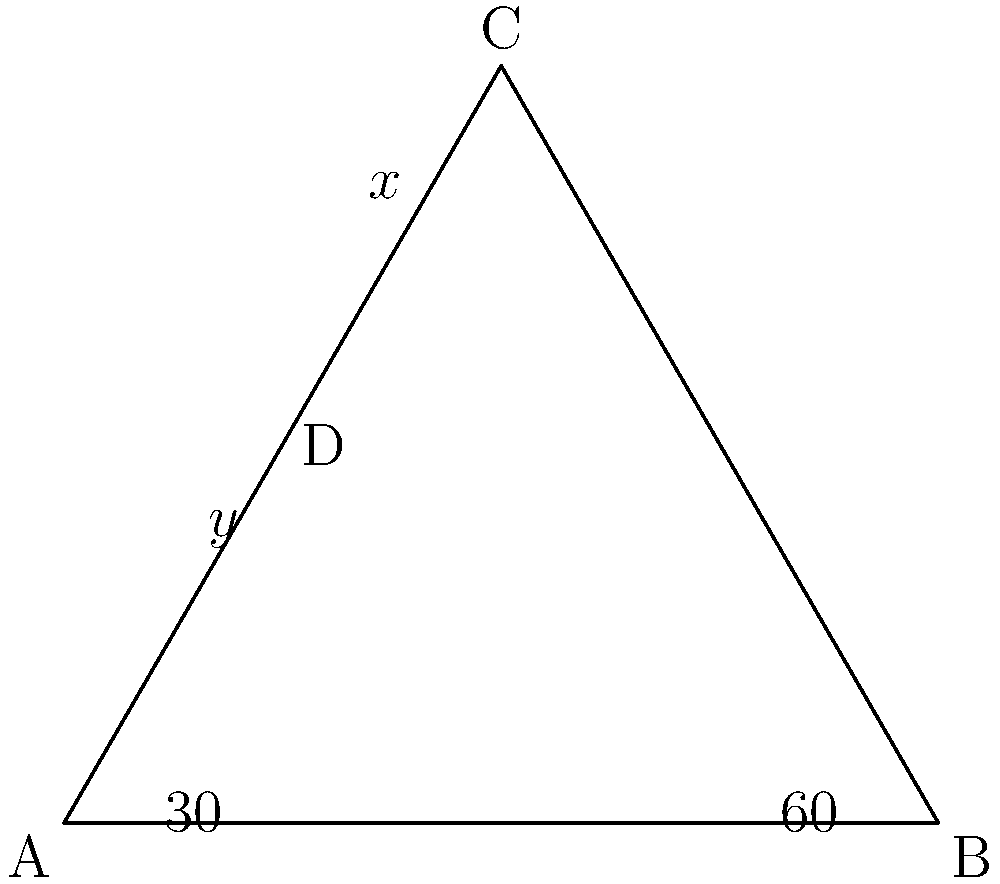In the diagram above, which represents a simplified mountain landscape typical of Nagorno-Karabakh, triangle ABC is equilateral. Point D lies on AC such that angle BAD is 30°. If x° represents the measure of angle BCD and y° represents the measure of angle ADB, what is the value of x + y? Let's approach this step-by-step:

1) In an equilateral triangle, all angles are 60°. So, angle ABC = 60°.

2) We're given that angle BAD = 30°. Since ABC is equilateral, we know that angle BAC = 60°.

3) Therefore, angle CAD = 60° - 30° = 30°.

4) In triangle ADB:
   - Angle BAD = 30°
   - Angle ADB = y°
   - The sum of angles in a triangle is 180°, so:
     30° + y° + 30° = 180°
     y° = 120°

5) Now, let's look at triangle BCD:
   - Angle BCD = x°
   - Angle CBD = 60° (from the equilateral triangle)
   - Again, the sum of angles in a triangle is 180°, so:
     x° + 60° + 60° = 180°
     x° = 60°

6) The question asks for x + y:
   x + y = 60° + 120° = 180°

Therefore, the sum of x and y is 180°.
Answer: 180° 